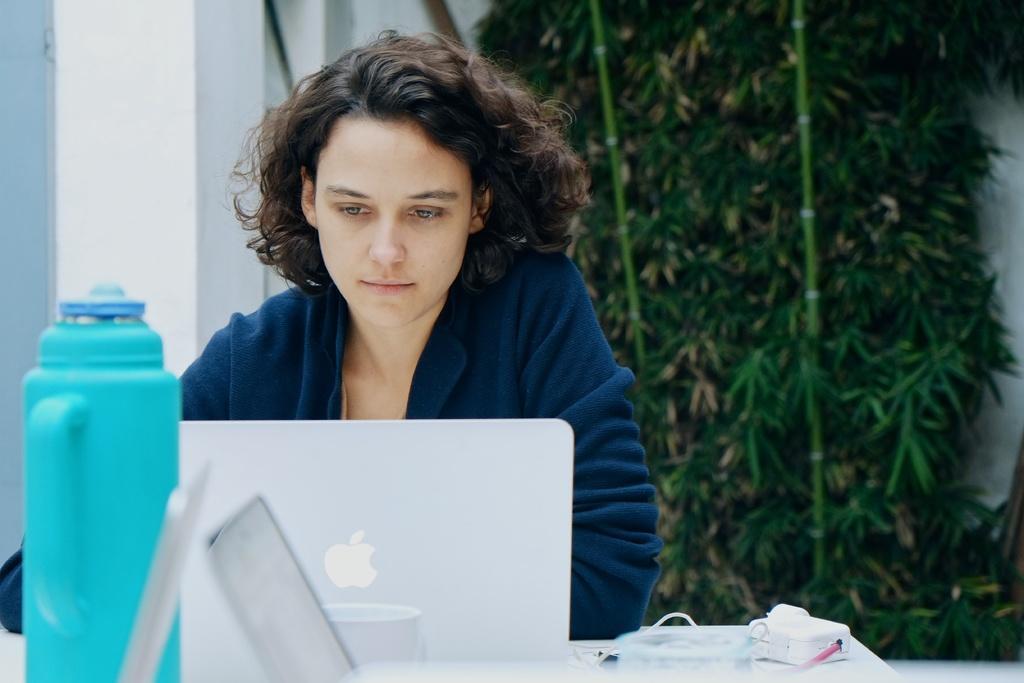Could you give a brief overview of what you see in this image? As we can see in the image there is a white color wall, tree, a table and women over here. On table there is a bottle and laptop. 